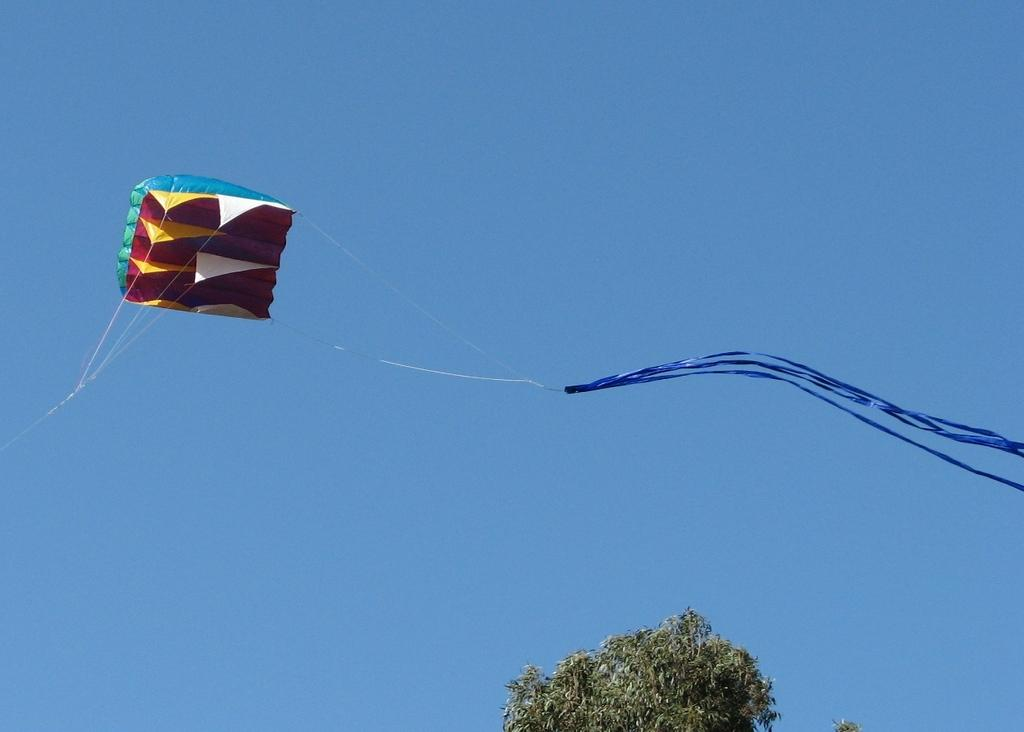What is flying in the air in the image? There is a kite flying in the air in the image. What can be seen in the background of the image? There is a tree present in the image. What type of soup is being served in the image? There is no soup present in the image; it features a kite flying in the air and a tree in the background. Can you describe the taste of the eggs in the image? There are no eggs present in the image, so it is not possible to describe their taste. 